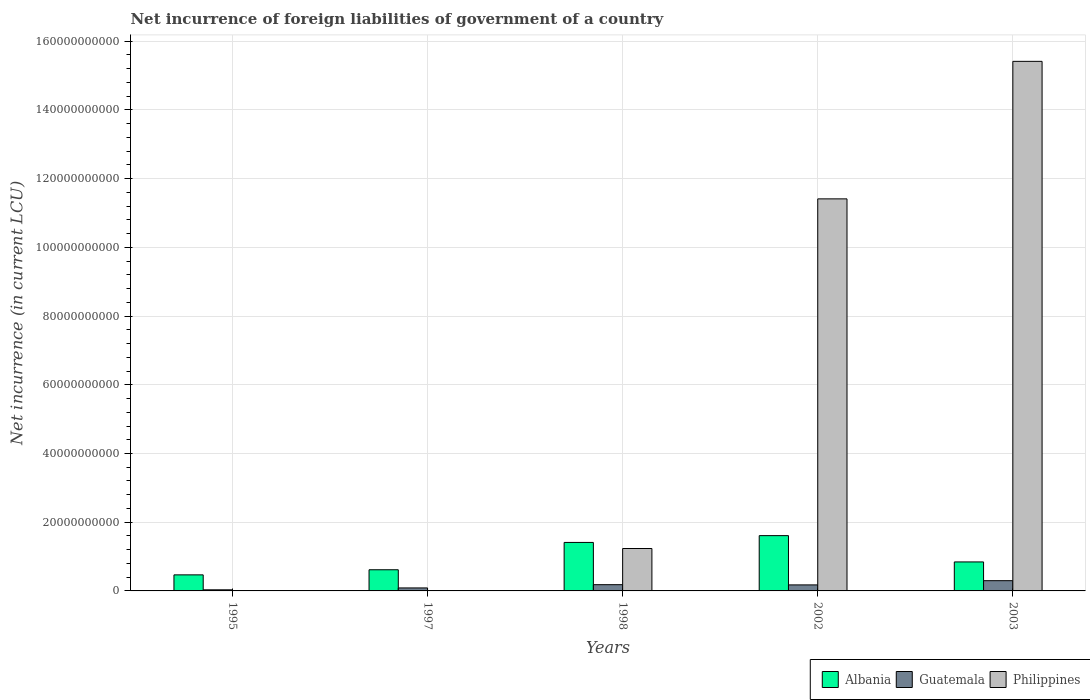How many different coloured bars are there?
Give a very brief answer. 3. How many groups of bars are there?
Provide a succinct answer. 5. Are the number of bars per tick equal to the number of legend labels?
Your answer should be very brief. No. Are the number of bars on each tick of the X-axis equal?
Provide a succinct answer. No. How many bars are there on the 4th tick from the right?
Your answer should be very brief. 2. In how many cases, is the number of bars for a given year not equal to the number of legend labels?
Offer a terse response. 2. What is the net incurrence of foreign liabilities in Albania in 2003?
Offer a terse response. 8.44e+09. Across all years, what is the maximum net incurrence of foreign liabilities in Albania?
Offer a very short reply. 1.61e+1. Across all years, what is the minimum net incurrence of foreign liabilities in Albania?
Your answer should be very brief. 4.67e+09. In which year was the net incurrence of foreign liabilities in Guatemala maximum?
Your answer should be very brief. 2003. What is the total net incurrence of foreign liabilities in Guatemala in the graph?
Offer a very short reply. 7.74e+09. What is the difference between the net incurrence of foreign liabilities in Guatemala in 1998 and that in 2002?
Keep it short and to the point. 6.65e+07. What is the difference between the net incurrence of foreign liabilities in Albania in 1998 and the net incurrence of foreign liabilities in Philippines in 1995?
Your answer should be compact. 1.41e+1. What is the average net incurrence of foreign liabilities in Albania per year?
Your answer should be very brief. 9.89e+09. In the year 2002, what is the difference between the net incurrence of foreign liabilities in Albania and net incurrence of foreign liabilities in Philippines?
Give a very brief answer. -9.80e+1. In how many years, is the net incurrence of foreign liabilities in Guatemala greater than 4000000000 LCU?
Give a very brief answer. 0. What is the ratio of the net incurrence of foreign liabilities in Guatemala in 1997 to that in 2002?
Offer a terse response. 0.5. What is the difference between the highest and the second highest net incurrence of foreign liabilities in Albania?
Offer a very short reply. 1.98e+09. What is the difference between the highest and the lowest net incurrence of foreign liabilities in Philippines?
Your answer should be very brief. 1.54e+11. Is the sum of the net incurrence of foreign liabilities in Albania in 2002 and 2003 greater than the maximum net incurrence of foreign liabilities in Philippines across all years?
Your response must be concise. No. How many bars are there?
Ensure brevity in your answer.  13. Are all the bars in the graph horizontal?
Your response must be concise. No. What is the difference between two consecutive major ticks on the Y-axis?
Provide a short and direct response. 2.00e+1. Does the graph contain any zero values?
Offer a very short reply. Yes. Where does the legend appear in the graph?
Your answer should be compact. Bottom right. How are the legend labels stacked?
Your answer should be very brief. Horizontal. What is the title of the graph?
Your answer should be very brief. Net incurrence of foreign liabilities of government of a country. Does "Libya" appear as one of the legend labels in the graph?
Keep it short and to the point. No. What is the label or title of the Y-axis?
Offer a very short reply. Net incurrence (in current LCU). What is the Net incurrence (in current LCU) in Albania in 1995?
Offer a very short reply. 4.67e+09. What is the Net incurrence (in current LCU) in Guatemala in 1995?
Make the answer very short. 3.21e+08. What is the Net incurrence (in current LCU) in Philippines in 1995?
Provide a succinct answer. 0. What is the Net incurrence (in current LCU) of Albania in 1997?
Ensure brevity in your answer.  6.16e+09. What is the Net incurrence (in current LCU) in Guatemala in 1997?
Give a very brief answer. 8.71e+08. What is the Net incurrence (in current LCU) of Albania in 1998?
Offer a terse response. 1.41e+1. What is the Net incurrence (in current LCU) in Guatemala in 1998?
Your answer should be very brief. 1.82e+09. What is the Net incurrence (in current LCU) in Philippines in 1998?
Your answer should be compact. 1.23e+1. What is the Net incurrence (in current LCU) in Albania in 2002?
Provide a succinct answer. 1.61e+1. What is the Net incurrence (in current LCU) of Guatemala in 2002?
Your answer should be compact. 1.75e+09. What is the Net incurrence (in current LCU) in Philippines in 2002?
Give a very brief answer. 1.14e+11. What is the Net incurrence (in current LCU) of Albania in 2003?
Offer a very short reply. 8.44e+09. What is the Net incurrence (in current LCU) of Guatemala in 2003?
Provide a short and direct response. 2.98e+09. What is the Net incurrence (in current LCU) in Philippines in 2003?
Keep it short and to the point. 1.54e+11. Across all years, what is the maximum Net incurrence (in current LCU) in Albania?
Keep it short and to the point. 1.61e+1. Across all years, what is the maximum Net incurrence (in current LCU) of Guatemala?
Offer a very short reply. 2.98e+09. Across all years, what is the maximum Net incurrence (in current LCU) in Philippines?
Make the answer very short. 1.54e+11. Across all years, what is the minimum Net incurrence (in current LCU) of Albania?
Keep it short and to the point. 4.67e+09. Across all years, what is the minimum Net incurrence (in current LCU) of Guatemala?
Give a very brief answer. 3.21e+08. What is the total Net incurrence (in current LCU) in Albania in the graph?
Your response must be concise. 4.95e+1. What is the total Net incurrence (in current LCU) in Guatemala in the graph?
Keep it short and to the point. 7.74e+09. What is the total Net incurrence (in current LCU) of Philippines in the graph?
Provide a short and direct response. 2.81e+11. What is the difference between the Net incurrence (in current LCU) of Albania in 1995 and that in 1997?
Your answer should be very brief. -1.49e+09. What is the difference between the Net incurrence (in current LCU) in Guatemala in 1995 and that in 1997?
Give a very brief answer. -5.50e+08. What is the difference between the Net incurrence (in current LCU) in Albania in 1995 and that in 1998?
Provide a succinct answer. -9.44e+09. What is the difference between the Net incurrence (in current LCU) of Guatemala in 1995 and that in 1998?
Offer a terse response. -1.50e+09. What is the difference between the Net incurrence (in current LCU) of Albania in 1995 and that in 2002?
Provide a succinct answer. -1.14e+1. What is the difference between the Net incurrence (in current LCU) of Guatemala in 1995 and that in 2002?
Offer a very short reply. -1.43e+09. What is the difference between the Net incurrence (in current LCU) of Albania in 1995 and that in 2003?
Make the answer very short. -3.77e+09. What is the difference between the Net incurrence (in current LCU) of Guatemala in 1995 and that in 2003?
Your answer should be compact. -2.66e+09. What is the difference between the Net incurrence (in current LCU) of Albania in 1997 and that in 1998?
Your response must be concise. -7.95e+09. What is the difference between the Net incurrence (in current LCU) of Guatemala in 1997 and that in 1998?
Make the answer very short. -9.47e+08. What is the difference between the Net incurrence (in current LCU) in Albania in 1997 and that in 2002?
Offer a very short reply. -9.93e+09. What is the difference between the Net incurrence (in current LCU) of Guatemala in 1997 and that in 2002?
Give a very brief answer. -8.81e+08. What is the difference between the Net incurrence (in current LCU) in Albania in 1997 and that in 2003?
Your answer should be very brief. -2.28e+09. What is the difference between the Net incurrence (in current LCU) of Guatemala in 1997 and that in 2003?
Offer a very short reply. -2.11e+09. What is the difference between the Net incurrence (in current LCU) of Albania in 1998 and that in 2002?
Offer a very short reply. -1.98e+09. What is the difference between the Net incurrence (in current LCU) in Guatemala in 1998 and that in 2002?
Provide a short and direct response. 6.65e+07. What is the difference between the Net incurrence (in current LCU) in Philippines in 1998 and that in 2002?
Your response must be concise. -1.02e+11. What is the difference between the Net incurrence (in current LCU) of Albania in 1998 and that in 2003?
Your answer should be compact. 5.67e+09. What is the difference between the Net incurrence (in current LCU) of Guatemala in 1998 and that in 2003?
Offer a very short reply. -1.16e+09. What is the difference between the Net incurrence (in current LCU) of Philippines in 1998 and that in 2003?
Offer a very short reply. -1.42e+11. What is the difference between the Net incurrence (in current LCU) in Albania in 2002 and that in 2003?
Keep it short and to the point. 7.65e+09. What is the difference between the Net incurrence (in current LCU) in Guatemala in 2002 and that in 2003?
Give a very brief answer. -1.23e+09. What is the difference between the Net incurrence (in current LCU) of Philippines in 2002 and that in 2003?
Make the answer very short. -4.00e+1. What is the difference between the Net incurrence (in current LCU) in Albania in 1995 and the Net incurrence (in current LCU) in Guatemala in 1997?
Your answer should be compact. 3.80e+09. What is the difference between the Net incurrence (in current LCU) of Albania in 1995 and the Net incurrence (in current LCU) of Guatemala in 1998?
Your answer should be very brief. 2.85e+09. What is the difference between the Net incurrence (in current LCU) in Albania in 1995 and the Net incurrence (in current LCU) in Philippines in 1998?
Offer a very short reply. -7.67e+09. What is the difference between the Net incurrence (in current LCU) in Guatemala in 1995 and the Net incurrence (in current LCU) in Philippines in 1998?
Offer a very short reply. -1.20e+1. What is the difference between the Net incurrence (in current LCU) of Albania in 1995 and the Net incurrence (in current LCU) of Guatemala in 2002?
Provide a short and direct response. 2.92e+09. What is the difference between the Net incurrence (in current LCU) in Albania in 1995 and the Net incurrence (in current LCU) in Philippines in 2002?
Give a very brief answer. -1.09e+11. What is the difference between the Net incurrence (in current LCU) in Guatemala in 1995 and the Net incurrence (in current LCU) in Philippines in 2002?
Offer a very short reply. -1.14e+11. What is the difference between the Net incurrence (in current LCU) in Albania in 1995 and the Net incurrence (in current LCU) in Guatemala in 2003?
Your answer should be very brief. 1.69e+09. What is the difference between the Net incurrence (in current LCU) of Albania in 1995 and the Net incurrence (in current LCU) of Philippines in 2003?
Keep it short and to the point. -1.49e+11. What is the difference between the Net incurrence (in current LCU) of Guatemala in 1995 and the Net incurrence (in current LCU) of Philippines in 2003?
Ensure brevity in your answer.  -1.54e+11. What is the difference between the Net incurrence (in current LCU) in Albania in 1997 and the Net incurrence (in current LCU) in Guatemala in 1998?
Offer a terse response. 4.34e+09. What is the difference between the Net incurrence (in current LCU) of Albania in 1997 and the Net incurrence (in current LCU) of Philippines in 1998?
Ensure brevity in your answer.  -6.19e+09. What is the difference between the Net incurrence (in current LCU) of Guatemala in 1997 and the Net incurrence (in current LCU) of Philippines in 1998?
Your response must be concise. -1.15e+1. What is the difference between the Net incurrence (in current LCU) in Albania in 1997 and the Net incurrence (in current LCU) in Guatemala in 2002?
Your answer should be compact. 4.41e+09. What is the difference between the Net incurrence (in current LCU) in Albania in 1997 and the Net incurrence (in current LCU) in Philippines in 2002?
Give a very brief answer. -1.08e+11. What is the difference between the Net incurrence (in current LCU) in Guatemala in 1997 and the Net incurrence (in current LCU) in Philippines in 2002?
Give a very brief answer. -1.13e+11. What is the difference between the Net incurrence (in current LCU) in Albania in 1997 and the Net incurrence (in current LCU) in Guatemala in 2003?
Your answer should be very brief. 3.18e+09. What is the difference between the Net incurrence (in current LCU) of Albania in 1997 and the Net incurrence (in current LCU) of Philippines in 2003?
Offer a terse response. -1.48e+11. What is the difference between the Net incurrence (in current LCU) in Guatemala in 1997 and the Net incurrence (in current LCU) in Philippines in 2003?
Make the answer very short. -1.53e+11. What is the difference between the Net incurrence (in current LCU) in Albania in 1998 and the Net incurrence (in current LCU) in Guatemala in 2002?
Offer a terse response. 1.24e+1. What is the difference between the Net incurrence (in current LCU) in Albania in 1998 and the Net incurrence (in current LCU) in Philippines in 2002?
Keep it short and to the point. -1.00e+11. What is the difference between the Net incurrence (in current LCU) of Guatemala in 1998 and the Net incurrence (in current LCU) of Philippines in 2002?
Offer a very short reply. -1.12e+11. What is the difference between the Net incurrence (in current LCU) in Albania in 1998 and the Net incurrence (in current LCU) in Guatemala in 2003?
Your answer should be compact. 1.11e+1. What is the difference between the Net incurrence (in current LCU) in Albania in 1998 and the Net incurrence (in current LCU) in Philippines in 2003?
Offer a very short reply. -1.40e+11. What is the difference between the Net incurrence (in current LCU) in Guatemala in 1998 and the Net incurrence (in current LCU) in Philippines in 2003?
Your response must be concise. -1.52e+11. What is the difference between the Net incurrence (in current LCU) of Albania in 2002 and the Net incurrence (in current LCU) of Guatemala in 2003?
Provide a succinct answer. 1.31e+1. What is the difference between the Net incurrence (in current LCU) in Albania in 2002 and the Net incurrence (in current LCU) in Philippines in 2003?
Make the answer very short. -1.38e+11. What is the difference between the Net incurrence (in current LCU) in Guatemala in 2002 and the Net incurrence (in current LCU) in Philippines in 2003?
Your response must be concise. -1.52e+11. What is the average Net incurrence (in current LCU) in Albania per year?
Your response must be concise. 9.89e+09. What is the average Net incurrence (in current LCU) in Guatemala per year?
Your response must be concise. 1.55e+09. What is the average Net incurrence (in current LCU) of Philippines per year?
Provide a short and direct response. 5.61e+1. In the year 1995, what is the difference between the Net incurrence (in current LCU) of Albania and Net incurrence (in current LCU) of Guatemala?
Offer a very short reply. 4.35e+09. In the year 1997, what is the difference between the Net incurrence (in current LCU) of Albania and Net incurrence (in current LCU) of Guatemala?
Your answer should be compact. 5.29e+09. In the year 1998, what is the difference between the Net incurrence (in current LCU) in Albania and Net incurrence (in current LCU) in Guatemala?
Ensure brevity in your answer.  1.23e+1. In the year 1998, what is the difference between the Net incurrence (in current LCU) in Albania and Net incurrence (in current LCU) in Philippines?
Keep it short and to the point. 1.77e+09. In the year 1998, what is the difference between the Net incurrence (in current LCU) of Guatemala and Net incurrence (in current LCU) of Philippines?
Keep it short and to the point. -1.05e+1. In the year 2002, what is the difference between the Net incurrence (in current LCU) in Albania and Net incurrence (in current LCU) in Guatemala?
Your response must be concise. 1.43e+1. In the year 2002, what is the difference between the Net incurrence (in current LCU) of Albania and Net incurrence (in current LCU) of Philippines?
Give a very brief answer. -9.80e+1. In the year 2002, what is the difference between the Net incurrence (in current LCU) of Guatemala and Net incurrence (in current LCU) of Philippines?
Offer a very short reply. -1.12e+11. In the year 2003, what is the difference between the Net incurrence (in current LCU) in Albania and Net incurrence (in current LCU) in Guatemala?
Make the answer very short. 5.46e+09. In the year 2003, what is the difference between the Net incurrence (in current LCU) in Albania and Net incurrence (in current LCU) in Philippines?
Keep it short and to the point. -1.46e+11. In the year 2003, what is the difference between the Net incurrence (in current LCU) in Guatemala and Net incurrence (in current LCU) in Philippines?
Offer a terse response. -1.51e+11. What is the ratio of the Net incurrence (in current LCU) of Albania in 1995 to that in 1997?
Give a very brief answer. 0.76. What is the ratio of the Net incurrence (in current LCU) in Guatemala in 1995 to that in 1997?
Offer a terse response. 0.37. What is the ratio of the Net incurrence (in current LCU) of Albania in 1995 to that in 1998?
Offer a very short reply. 0.33. What is the ratio of the Net incurrence (in current LCU) in Guatemala in 1995 to that in 1998?
Your answer should be very brief. 0.18. What is the ratio of the Net incurrence (in current LCU) in Albania in 1995 to that in 2002?
Your response must be concise. 0.29. What is the ratio of the Net incurrence (in current LCU) of Guatemala in 1995 to that in 2002?
Provide a short and direct response. 0.18. What is the ratio of the Net incurrence (in current LCU) of Albania in 1995 to that in 2003?
Keep it short and to the point. 0.55. What is the ratio of the Net incurrence (in current LCU) of Guatemala in 1995 to that in 2003?
Provide a short and direct response. 0.11. What is the ratio of the Net incurrence (in current LCU) in Albania in 1997 to that in 1998?
Provide a succinct answer. 0.44. What is the ratio of the Net incurrence (in current LCU) of Guatemala in 1997 to that in 1998?
Provide a succinct answer. 0.48. What is the ratio of the Net incurrence (in current LCU) of Albania in 1997 to that in 2002?
Your response must be concise. 0.38. What is the ratio of the Net incurrence (in current LCU) in Guatemala in 1997 to that in 2002?
Offer a very short reply. 0.5. What is the ratio of the Net incurrence (in current LCU) in Albania in 1997 to that in 2003?
Your answer should be compact. 0.73. What is the ratio of the Net incurrence (in current LCU) in Guatemala in 1997 to that in 2003?
Offer a terse response. 0.29. What is the ratio of the Net incurrence (in current LCU) in Albania in 1998 to that in 2002?
Ensure brevity in your answer.  0.88. What is the ratio of the Net incurrence (in current LCU) in Guatemala in 1998 to that in 2002?
Make the answer very short. 1.04. What is the ratio of the Net incurrence (in current LCU) in Philippines in 1998 to that in 2002?
Your response must be concise. 0.11. What is the ratio of the Net incurrence (in current LCU) of Albania in 1998 to that in 2003?
Your answer should be very brief. 1.67. What is the ratio of the Net incurrence (in current LCU) in Guatemala in 1998 to that in 2003?
Make the answer very short. 0.61. What is the ratio of the Net incurrence (in current LCU) in Philippines in 1998 to that in 2003?
Offer a very short reply. 0.08. What is the ratio of the Net incurrence (in current LCU) in Albania in 2002 to that in 2003?
Your response must be concise. 1.91. What is the ratio of the Net incurrence (in current LCU) of Guatemala in 2002 to that in 2003?
Offer a terse response. 0.59. What is the ratio of the Net incurrence (in current LCU) of Philippines in 2002 to that in 2003?
Provide a short and direct response. 0.74. What is the difference between the highest and the second highest Net incurrence (in current LCU) in Albania?
Your response must be concise. 1.98e+09. What is the difference between the highest and the second highest Net incurrence (in current LCU) of Guatemala?
Offer a terse response. 1.16e+09. What is the difference between the highest and the second highest Net incurrence (in current LCU) of Philippines?
Keep it short and to the point. 4.00e+1. What is the difference between the highest and the lowest Net incurrence (in current LCU) in Albania?
Offer a terse response. 1.14e+1. What is the difference between the highest and the lowest Net incurrence (in current LCU) in Guatemala?
Offer a terse response. 2.66e+09. What is the difference between the highest and the lowest Net incurrence (in current LCU) of Philippines?
Your response must be concise. 1.54e+11. 